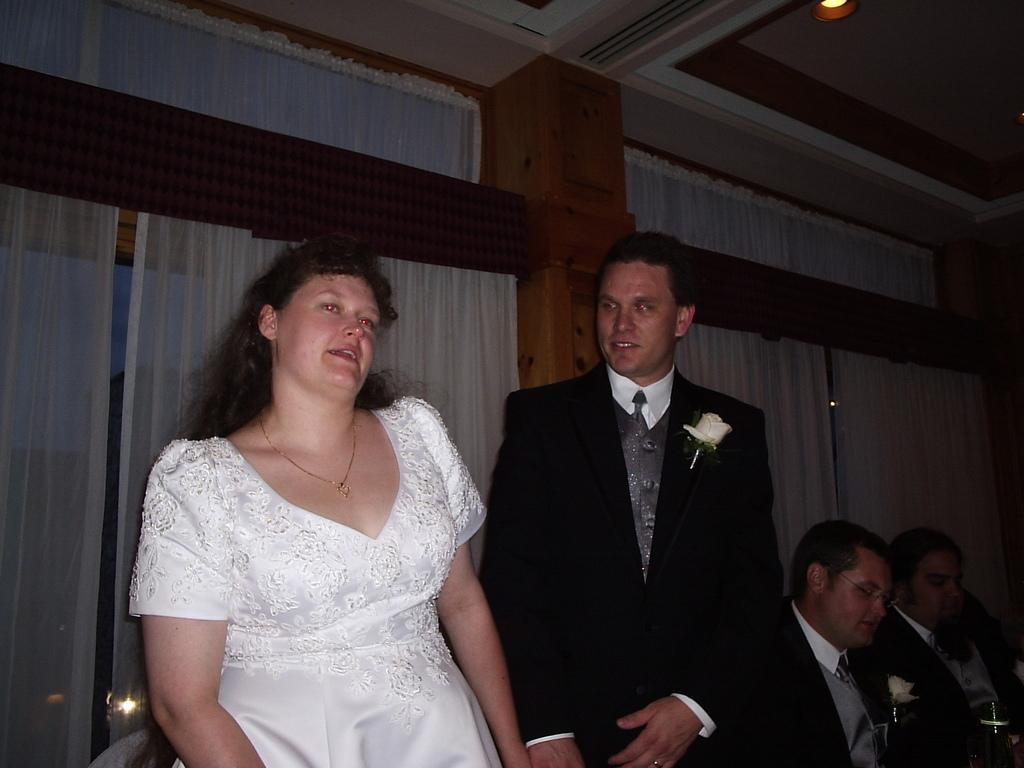How would you summarize this image in a sentence or two? In the picture we can see a man and a woman standing, woman is in a white dress and man is in blazer, tie and shirt with a flower to the blazer and beside them, we can see two men are sitting and behind them we can see a wall with white curtains, and to the ceiling we can see the light. 